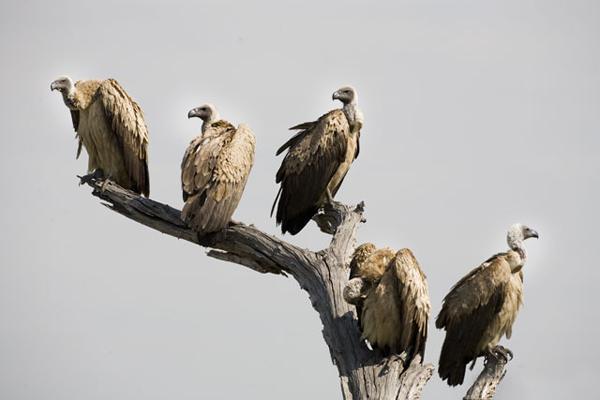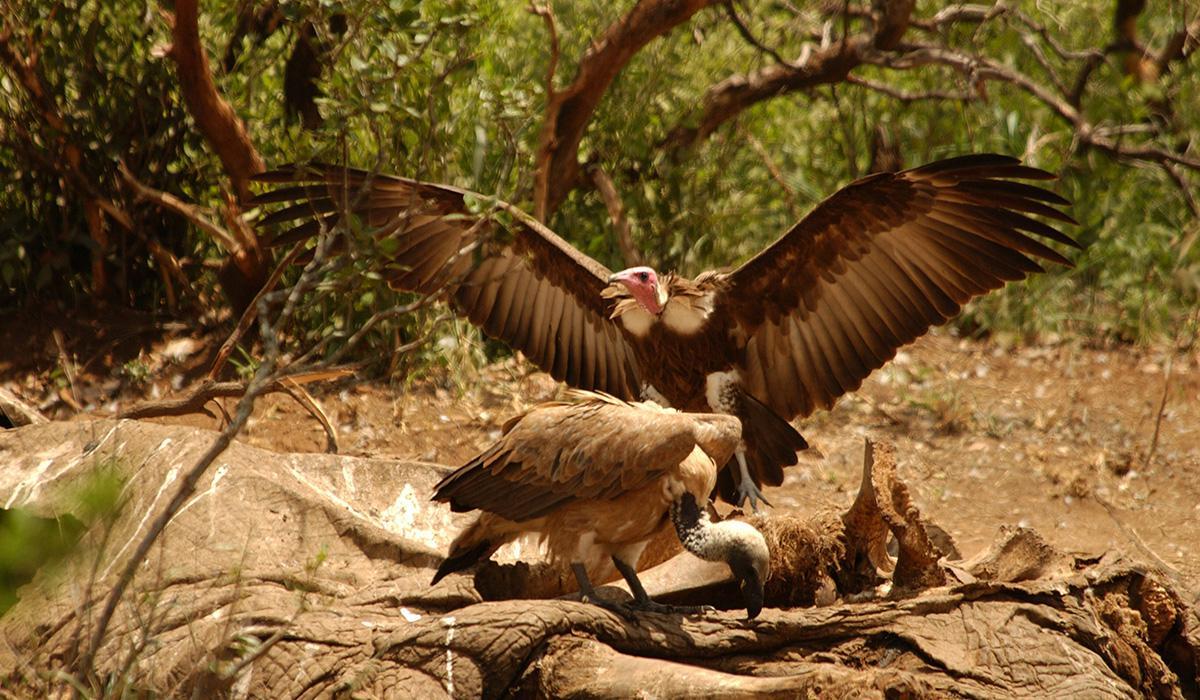The first image is the image on the left, the second image is the image on the right. Examine the images to the left and right. Is the description "The right image includes two vultures standing face-to-face." accurate? Answer yes or no. No. The first image is the image on the left, the second image is the image on the right. Given the left and right images, does the statement "In the image to the right, two vultures rest, wings closed." hold true? Answer yes or no. No. 